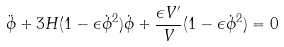Convert formula to latex. <formula><loc_0><loc_0><loc_500><loc_500>\ddot { \phi } + 3 H ( 1 - \epsilon \dot { \phi } ^ { 2 } ) \dot { \phi } + \frac { \epsilon V ^ { \prime } } { V } ( 1 - \epsilon \dot { \phi } ^ { 2 } ) = 0</formula> 